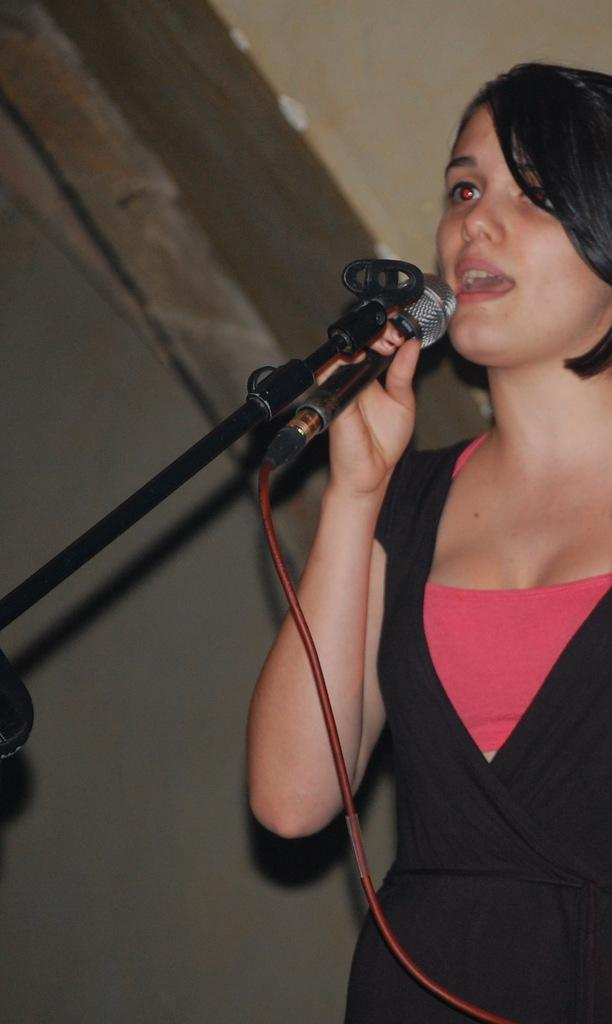Who is the main subject in the image? There is a lady in the image. What is the lady wearing? The lady is wearing a black and pink dress. What is the lady holding in her hand? The lady is holding a microphone in her hand. What is the lady doing in the image? The lady is singing. What can be seen connected to the microphone? There is a red wire connected to the microphone. What type of fish can be seen swimming in the background of the image? There are no fish present in the image; it features a lady singing with a microphone. What vegetables are being used as props in the image? There are no vegetables present in the image; it features a lady singing with a microphone. 